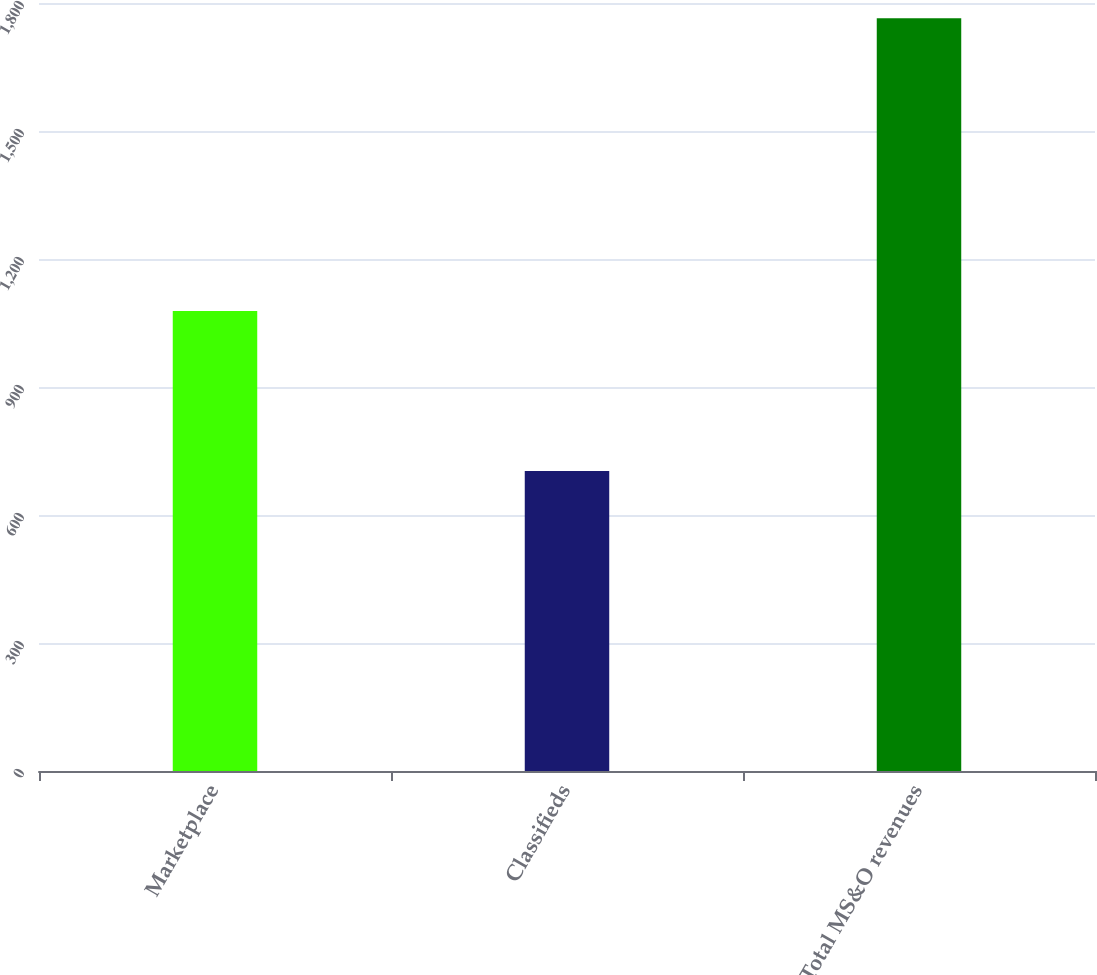<chart> <loc_0><loc_0><loc_500><loc_500><bar_chart><fcel>Marketplace<fcel>Classifieds<fcel>Total MS&O revenues<nl><fcel>1078<fcel>703<fcel>1764<nl></chart> 